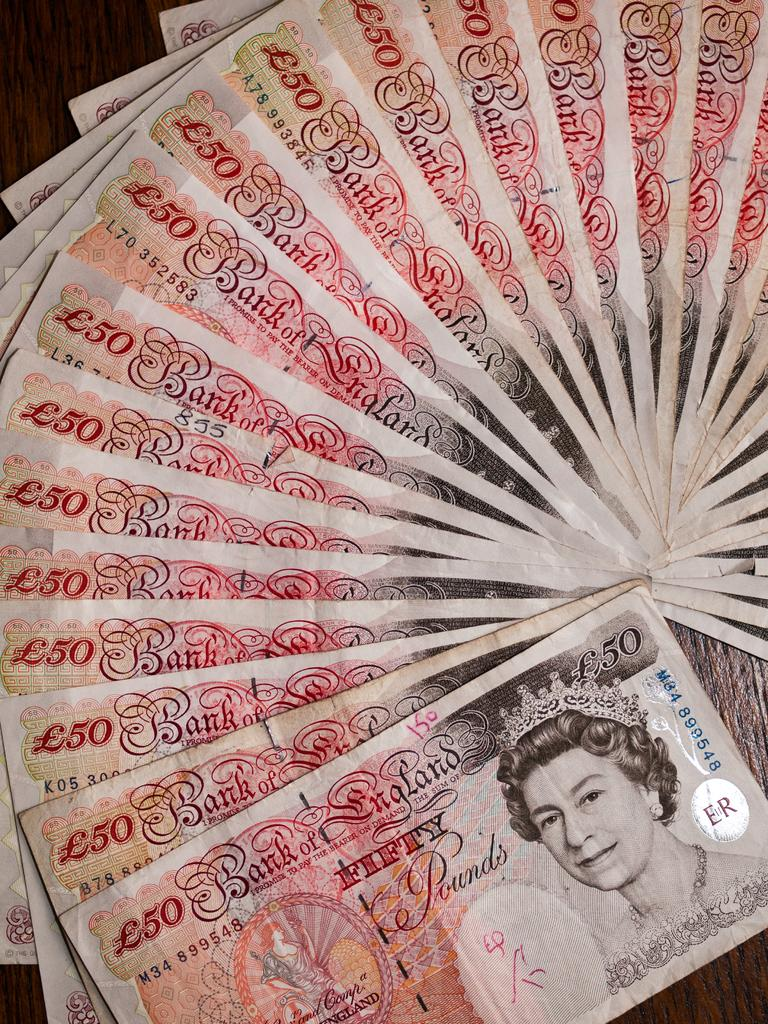What type of currency is depicted in the image? The banknotes in the image are of the pound sterling. Can you describe any specific features on the banknotes? Yes, there is a picture of a woman with a crown on one of the banknotes. What type of caption is written below the picture of the woman with a crown? There is no caption written below the picture of the woman with a crown in the image. 